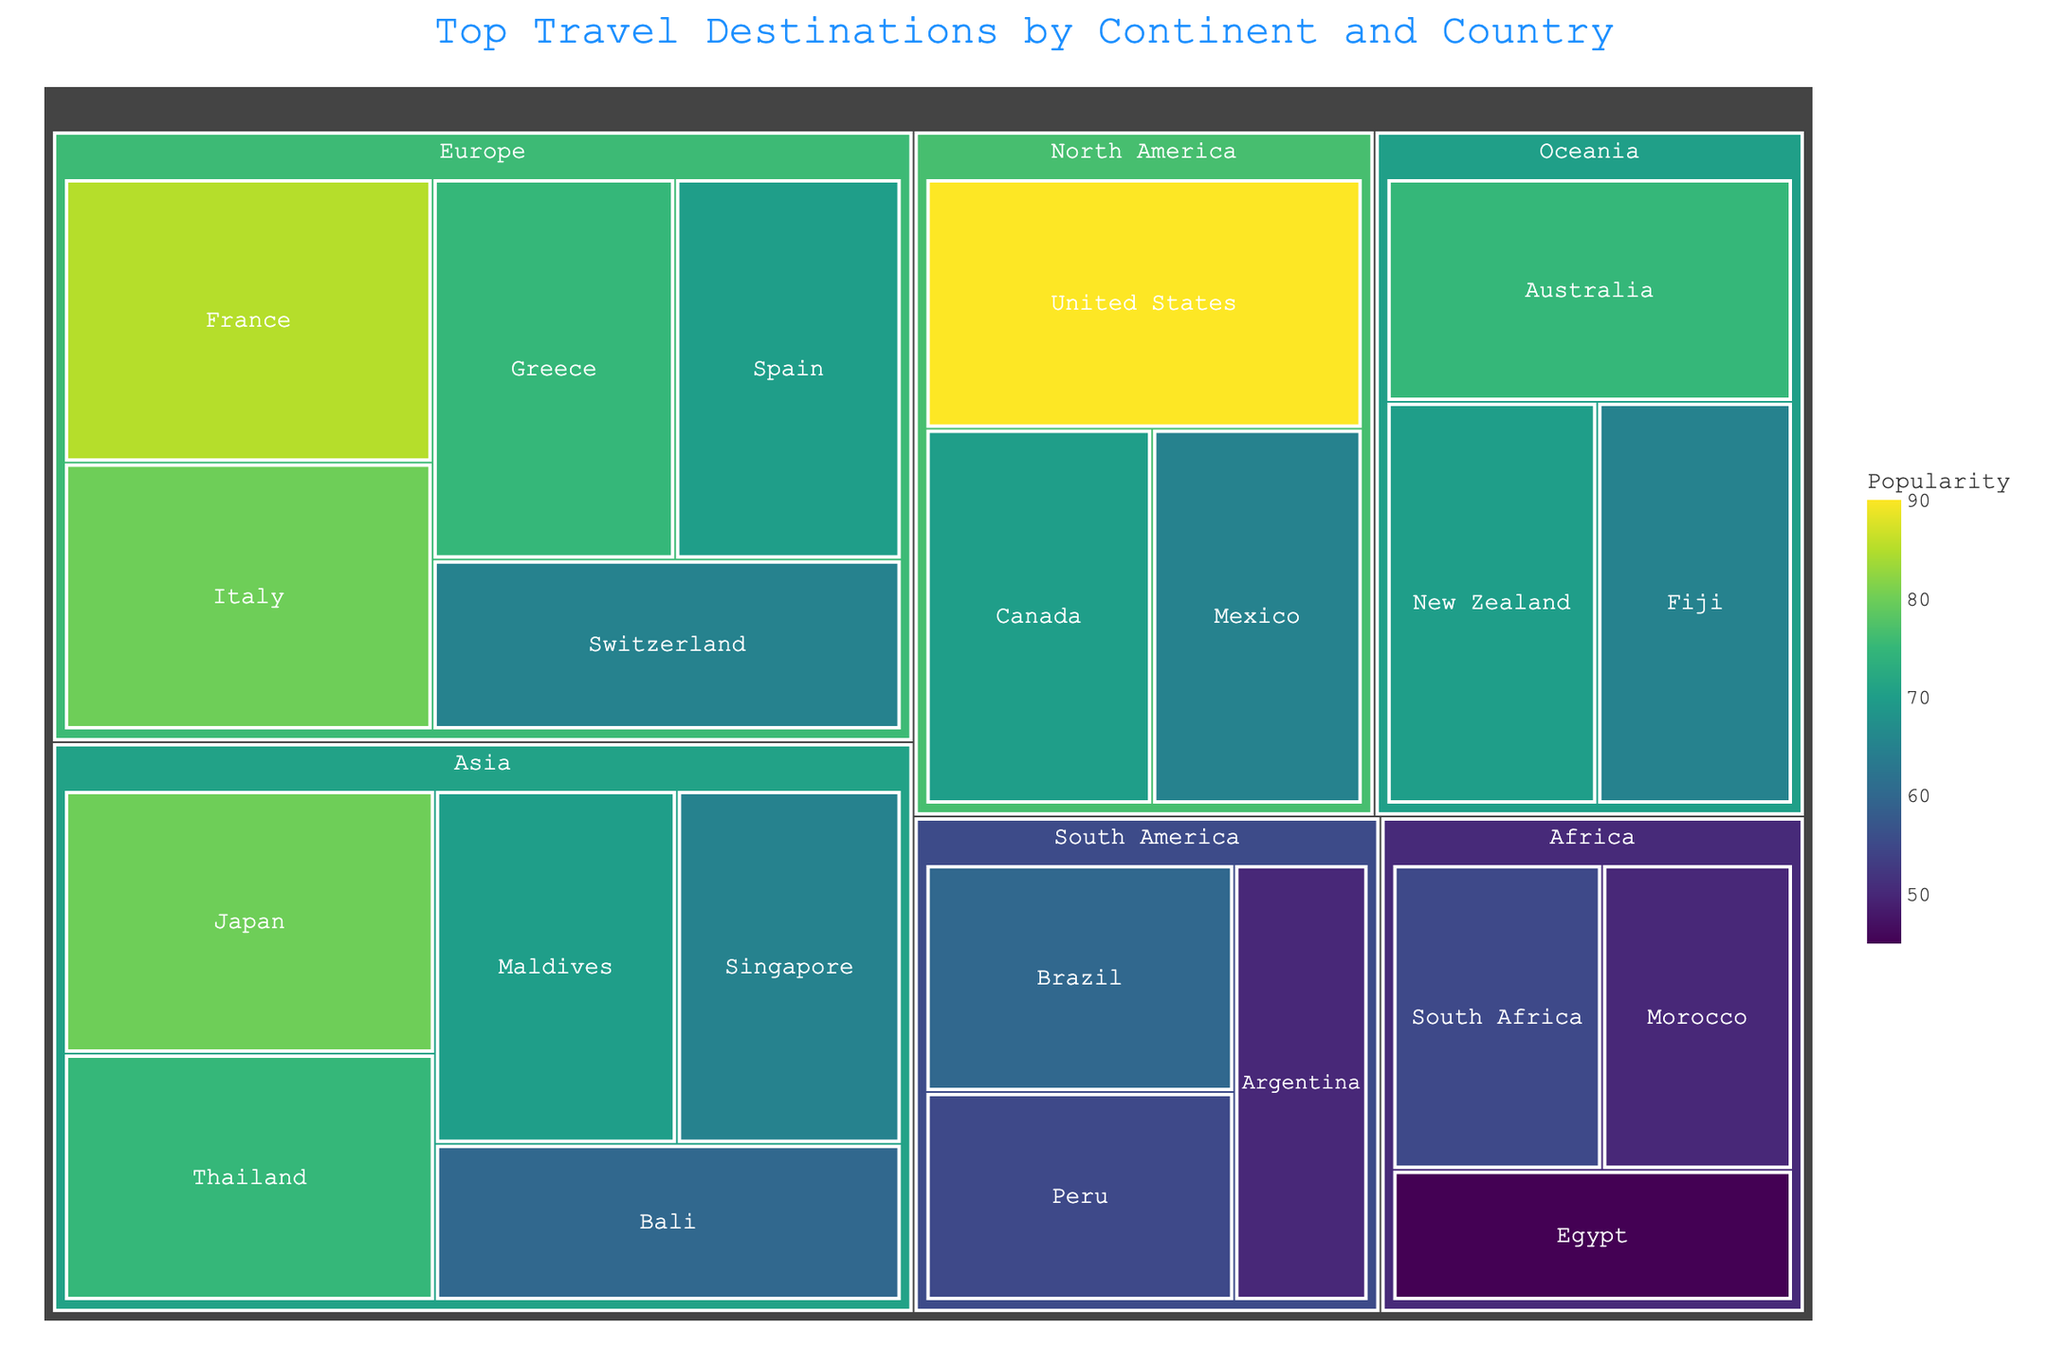what's the most popular travel destination? The largest segment or the one with the highest value in the treemap would represent the most popular travel destination. By looking for the highest numeric value, you can identify "United States" with a value of 90
Answer: United States What is the popularity difference between the least and most popular destinations in Asia? To find this, identify the most and least popular destinations in Asia. The most popular is Japan (80), and the least is Bali (60). The difference is 80 - 60.
Answer: 20 Which continent has the highest cumulative popularity? Summing the popularity values for each continent and comparing them is needed. North America's total is 90 (US) + 70 (Canada) + 65 (Mexico) = 225. This is higher compared to other continents.
Answer: North America Which country in Africa is the most popular travel destination? By examining the African segment in the treemap, South Africa has the highest value (55).
Answer: South Africa How many countries in Europe have a popularity score of 70 or higher? In the European section, identify countries with scores 70 or above: France (85), Italy (80), Greece (75), and Spain (70). There are four such countries.
Answer: 4 What is the popularity score for the least popular country in South America? Check each segment within South America for the lowest score. Argentina has the smallest value (50).
Answer: 50 If you combine the popularity scores for all countries in Oceania, what is the total? Add the popularity figures for Australia (75), New Zealand (70), and Fiji (65). The total is 75 + 70 + 65.
Answer: 210 Which continent has the most countries listed as travel destinations? By counting the unique countries in each continent displayed. Asia has Japan, Thailand, Maldives, Singapore, Bali (total 5).
Answer: Asia Which country in Europe has the lowest popularity? Among the European countries, Switzerland has the lowest popularity score (65).
Answer: Switzerland Do any continents have a country with a popularity score above 90? Comparing all values, only North America’s United States has a score of 90, which is the highest and no other score exceeds this value.
Answer: No 